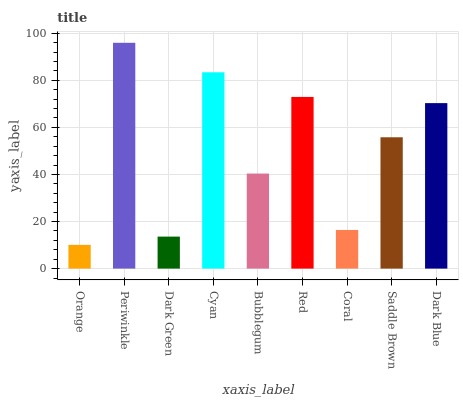Is Orange the minimum?
Answer yes or no. Yes. Is Periwinkle the maximum?
Answer yes or no. Yes. Is Dark Green the minimum?
Answer yes or no. No. Is Dark Green the maximum?
Answer yes or no. No. Is Periwinkle greater than Dark Green?
Answer yes or no. Yes. Is Dark Green less than Periwinkle?
Answer yes or no. Yes. Is Dark Green greater than Periwinkle?
Answer yes or no. No. Is Periwinkle less than Dark Green?
Answer yes or no. No. Is Saddle Brown the high median?
Answer yes or no. Yes. Is Saddle Brown the low median?
Answer yes or no. Yes. Is Bubblegum the high median?
Answer yes or no. No. Is Cyan the low median?
Answer yes or no. No. 